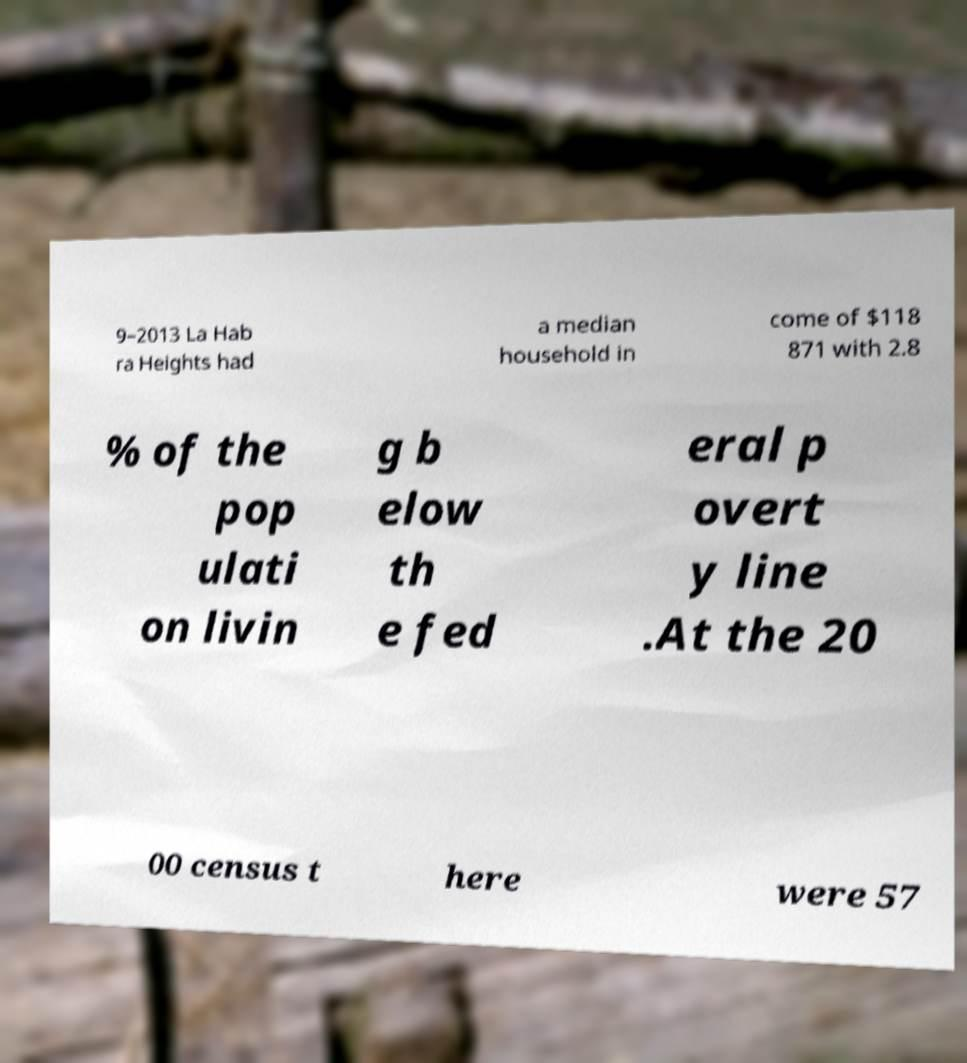Could you assist in decoding the text presented in this image and type it out clearly? 9–2013 La Hab ra Heights had a median household in come of $118 871 with 2.8 % of the pop ulati on livin g b elow th e fed eral p overt y line .At the 20 00 census t here were 57 